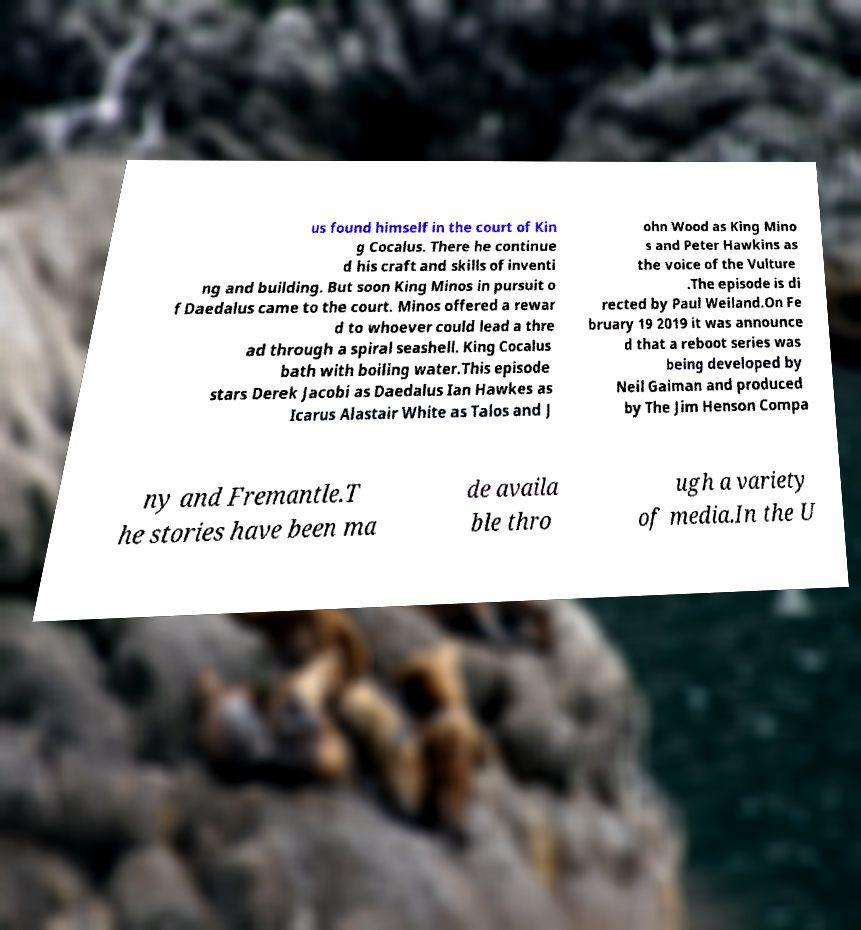Please identify and transcribe the text found in this image. us found himself in the court of Kin g Cocalus. There he continue d his craft and skills of inventi ng and building. But soon King Minos in pursuit o f Daedalus came to the court. Minos offered a rewar d to whoever could lead a thre ad through a spiral seashell. King Cocalus bath with boiling water.This episode stars Derek Jacobi as Daedalus Ian Hawkes as Icarus Alastair White as Talos and J ohn Wood as King Mino s and Peter Hawkins as the voice of the Vulture .The episode is di rected by Paul Weiland.On Fe bruary 19 2019 it was announce d that a reboot series was being developed by Neil Gaiman and produced by The Jim Henson Compa ny and Fremantle.T he stories have been ma de availa ble thro ugh a variety of media.In the U 